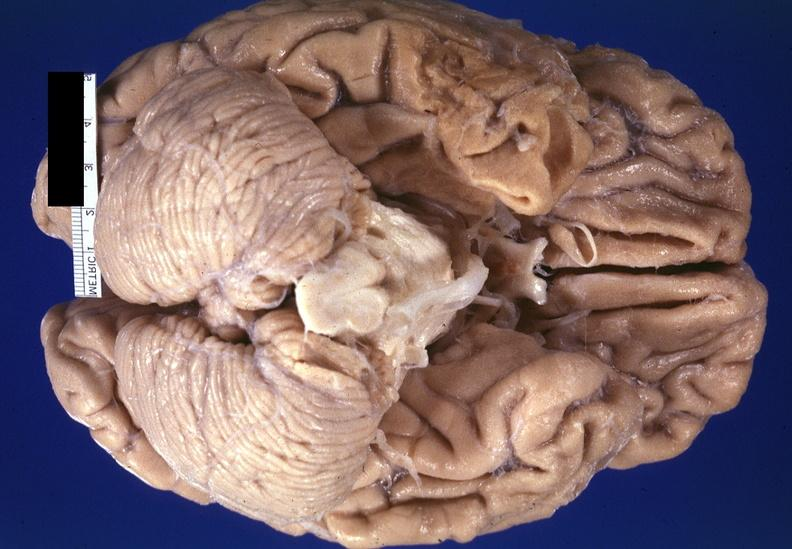does ear lobe horizontal crease show brain, frontal lobe atrophy, pick 's disease?
Answer the question using a single word or phrase. No 